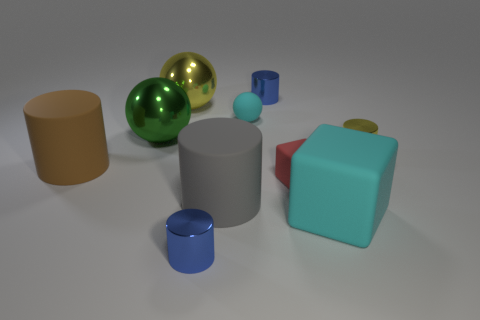How many objects are there and can you describe their colors? There are seven objects in the image. Starting from the left, there is a brown cylinder, a green and a gold sphere, a light blue small sphere, a gray cylinder, a red cylinder resting on top of a teal cube, and a small yellow cylinder. 